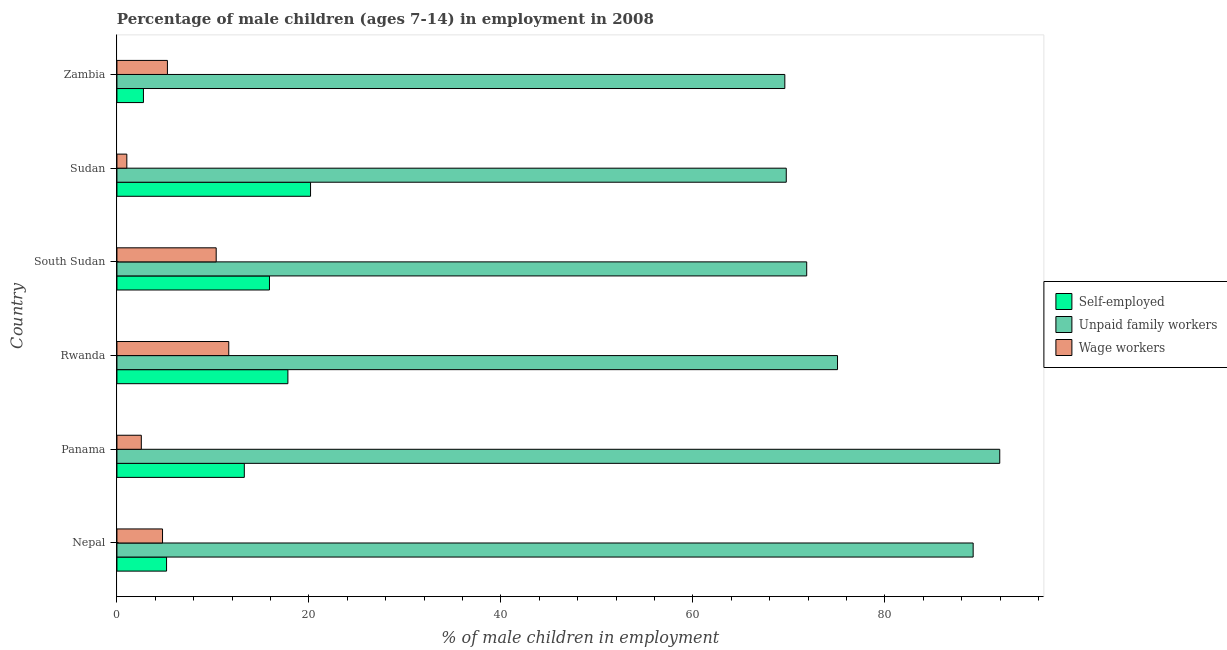How many bars are there on the 2nd tick from the bottom?
Provide a succinct answer. 3. What is the label of the 1st group of bars from the top?
Ensure brevity in your answer.  Zambia. In how many cases, is the number of bars for a given country not equal to the number of legend labels?
Ensure brevity in your answer.  0. What is the percentage of children employed as unpaid family workers in Sudan?
Your response must be concise. 69.73. Across all countries, what is the maximum percentage of children employed as wage workers?
Your response must be concise. 11.65. Across all countries, what is the minimum percentage of self employed children?
Ensure brevity in your answer.  2.76. In which country was the percentage of children employed as unpaid family workers maximum?
Ensure brevity in your answer.  Panama. In which country was the percentage of children employed as wage workers minimum?
Provide a short and direct response. Sudan. What is the total percentage of children employed as unpaid family workers in the graph?
Your answer should be very brief. 467.41. What is the difference between the percentage of children employed as wage workers in Rwanda and that in Zambia?
Provide a short and direct response. 6.39. What is the difference between the percentage of self employed children in Zambia and the percentage of children employed as wage workers in Sudan?
Provide a short and direct response. 1.73. What is the average percentage of children employed as wage workers per country?
Keep it short and to the point. 5.93. What is the difference between the percentage of children employed as unpaid family workers and percentage of self employed children in Rwanda?
Provide a short and direct response. 57.26. What is the ratio of the percentage of children employed as wage workers in Rwanda to that in South Sudan?
Make the answer very short. 1.13. Is the percentage of children employed as unpaid family workers in Panama less than that in Rwanda?
Keep it short and to the point. No. What is the difference between the highest and the second highest percentage of self employed children?
Offer a terse response. 2.36. What is the difference between the highest and the lowest percentage of children employed as wage workers?
Provide a short and direct response. 10.62. In how many countries, is the percentage of children employed as unpaid family workers greater than the average percentage of children employed as unpaid family workers taken over all countries?
Your answer should be compact. 2. Is the sum of the percentage of children employed as wage workers in South Sudan and Sudan greater than the maximum percentage of children employed as unpaid family workers across all countries?
Offer a very short reply. No. What does the 2nd bar from the top in Rwanda represents?
Offer a terse response. Unpaid family workers. What does the 3rd bar from the bottom in South Sudan represents?
Offer a very short reply. Wage workers. How many countries are there in the graph?
Your answer should be compact. 6. Are the values on the major ticks of X-axis written in scientific E-notation?
Offer a terse response. No. Does the graph contain any zero values?
Your response must be concise. No. How are the legend labels stacked?
Provide a succinct answer. Vertical. What is the title of the graph?
Keep it short and to the point. Percentage of male children (ages 7-14) in employment in 2008. Does "Communicable diseases" appear as one of the legend labels in the graph?
Your answer should be compact. No. What is the label or title of the X-axis?
Your answer should be very brief. % of male children in employment. What is the label or title of the Y-axis?
Your answer should be compact. Country. What is the % of male children in employment in Self-employed in Nepal?
Provide a short and direct response. 5.17. What is the % of male children in employment in Unpaid family workers in Nepal?
Keep it short and to the point. 89.2. What is the % of male children in employment of Wage workers in Nepal?
Your response must be concise. 4.75. What is the % of male children in employment in Self-employed in Panama?
Make the answer very short. 13.27. What is the % of male children in employment of Unpaid family workers in Panama?
Your answer should be compact. 91.97. What is the % of male children in employment of Wage workers in Panama?
Ensure brevity in your answer.  2.54. What is the % of male children in employment of Self-employed in Rwanda?
Provide a short and direct response. 17.81. What is the % of male children in employment in Unpaid family workers in Rwanda?
Offer a very short reply. 75.07. What is the % of male children in employment of Wage workers in Rwanda?
Provide a succinct answer. 11.65. What is the % of male children in employment in Self-employed in South Sudan?
Provide a succinct answer. 15.89. What is the % of male children in employment of Unpaid family workers in South Sudan?
Give a very brief answer. 71.86. What is the % of male children in employment of Wage workers in South Sudan?
Offer a terse response. 10.34. What is the % of male children in employment in Self-employed in Sudan?
Give a very brief answer. 20.17. What is the % of male children in employment in Unpaid family workers in Sudan?
Your response must be concise. 69.73. What is the % of male children in employment in Self-employed in Zambia?
Ensure brevity in your answer.  2.76. What is the % of male children in employment in Unpaid family workers in Zambia?
Your answer should be compact. 69.58. What is the % of male children in employment of Wage workers in Zambia?
Provide a short and direct response. 5.26. Across all countries, what is the maximum % of male children in employment in Self-employed?
Ensure brevity in your answer.  20.17. Across all countries, what is the maximum % of male children in employment of Unpaid family workers?
Offer a terse response. 91.97. Across all countries, what is the maximum % of male children in employment in Wage workers?
Offer a very short reply. 11.65. Across all countries, what is the minimum % of male children in employment of Self-employed?
Ensure brevity in your answer.  2.76. Across all countries, what is the minimum % of male children in employment of Unpaid family workers?
Keep it short and to the point. 69.58. What is the total % of male children in employment in Self-employed in the graph?
Make the answer very short. 75.07. What is the total % of male children in employment in Unpaid family workers in the graph?
Ensure brevity in your answer.  467.41. What is the total % of male children in employment of Wage workers in the graph?
Give a very brief answer. 35.57. What is the difference between the % of male children in employment in Unpaid family workers in Nepal and that in Panama?
Your answer should be compact. -2.77. What is the difference between the % of male children in employment in Wage workers in Nepal and that in Panama?
Give a very brief answer. 2.21. What is the difference between the % of male children in employment in Self-employed in Nepal and that in Rwanda?
Offer a very short reply. -12.64. What is the difference between the % of male children in employment of Unpaid family workers in Nepal and that in Rwanda?
Make the answer very short. 14.13. What is the difference between the % of male children in employment of Wage workers in Nepal and that in Rwanda?
Make the answer very short. -6.9. What is the difference between the % of male children in employment of Self-employed in Nepal and that in South Sudan?
Make the answer very short. -10.72. What is the difference between the % of male children in employment in Unpaid family workers in Nepal and that in South Sudan?
Your answer should be compact. 17.34. What is the difference between the % of male children in employment in Wage workers in Nepal and that in South Sudan?
Make the answer very short. -5.59. What is the difference between the % of male children in employment in Self-employed in Nepal and that in Sudan?
Offer a terse response. -15. What is the difference between the % of male children in employment in Unpaid family workers in Nepal and that in Sudan?
Keep it short and to the point. 19.47. What is the difference between the % of male children in employment in Wage workers in Nepal and that in Sudan?
Your answer should be compact. 3.72. What is the difference between the % of male children in employment of Self-employed in Nepal and that in Zambia?
Give a very brief answer. 2.41. What is the difference between the % of male children in employment of Unpaid family workers in Nepal and that in Zambia?
Give a very brief answer. 19.62. What is the difference between the % of male children in employment in Wage workers in Nepal and that in Zambia?
Offer a very short reply. -0.51. What is the difference between the % of male children in employment in Self-employed in Panama and that in Rwanda?
Your response must be concise. -4.54. What is the difference between the % of male children in employment of Wage workers in Panama and that in Rwanda?
Offer a very short reply. -9.11. What is the difference between the % of male children in employment of Self-employed in Panama and that in South Sudan?
Your answer should be very brief. -2.62. What is the difference between the % of male children in employment in Unpaid family workers in Panama and that in South Sudan?
Ensure brevity in your answer.  20.11. What is the difference between the % of male children in employment of Wage workers in Panama and that in South Sudan?
Make the answer very short. -7.8. What is the difference between the % of male children in employment in Self-employed in Panama and that in Sudan?
Ensure brevity in your answer.  -6.9. What is the difference between the % of male children in employment of Unpaid family workers in Panama and that in Sudan?
Offer a very short reply. 22.24. What is the difference between the % of male children in employment of Wage workers in Panama and that in Sudan?
Your response must be concise. 1.51. What is the difference between the % of male children in employment of Self-employed in Panama and that in Zambia?
Ensure brevity in your answer.  10.51. What is the difference between the % of male children in employment of Unpaid family workers in Panama and that in Zambia?
Keep it short and to the point. 22.39. What is the difference between the % of male children in employment in Wage workers in Panama and that in Zambia?
Give a very brief answer. -2.72. What is the difference between the % of male children in employment in Self-employed in Rwanda and that in South Sudan?
Give a very brief answer. 1.92. What is the difference between the % of male children in employment in Unpaid family workers in Rwanda and that in South Sudan?
Provide a succinct answer. 3.21. What is the difference between the % of male children in employment in Wage workers in Rwanda and that in South Sudan?
Ensure brevity in your answer.  1.31. What is the difference between the % of male children in employment in Self-employed in Rwanda and that in Sudan?
Give a very brief answer. -2.36. What is the difference between the % of male children in employment of Unpaid family workers in Rwanda and that in Sudan?
Ensure brevity in your answer.  5.34. What is the difference between the % of male children in employment of Wage workers in Rwanda and that in Sudan?
Provide a short and direct response. 10.62. What is the difference between the % of male children in employment in Self-employed in Rwanda and that in Zambia?
Provide a short and direct response. 15.05. What is the difference between the % of male children in employment of Unpaid family workers in Rwanda and that in Zambia?
Ensure brevity in your answer.  5.49. What is the difference between the % of male children in employment in Wage workers in Rwanda and that in Zambia?
Your answer should be very brief. 6.39. What is the difference between the % of male children in employment in Self-employed in South Sudan and that in Sudan?
Your answer should be compact. -4.28. What is the difference between the % of male children in employment in Unpaid family workers in South Sudan and that in Sudan?
Your response must be concise. 2.13. What is the difference between the % of male children in employment in Wage workers in South Sudan and that in Sudan?
Ensure brevity in your answer.  9.31. What is the difference between the % of male children in employment in Self-employed in South Sudan and that in Zambia?
Your response must be concise. 13.13. What is the difference between the % of male children in employment in Unpaid family workers in South Sudan and that in Zambia?
Your answer should be very brief. 2.28. What is the difference between the % of male children in employment in Wage workers in South Sudan and that in Zambia?
Give a very brief answer. 5.08. What is the difference between the % of male children in employment in Self-employed in Sudan and that in Zambia?
Make the answer very short. 17.41. What is the difference between the % of male children in employment in Unpaid family workers in Sudan and that in Zambia?
Give a very brief answer. 0.15. What is the difference between the % of male children in employment in Wage workers in Sudan and that in Zambia?
Your answer should be compact. -4.23. What is the difference between the % of male children in employment in Self-employed in Nepal and the % of male children in employment in Unpaid family workers in Panama?
Provide a succinct answer. -86.8. What is the difference between the % of male children in employment of Self-employed in Nepal and the % of male children in employment of Wage workers in Panama?
Your response must be concise. 2.63. What is the difference between the % of male children in employment in Unpaid family workers in Nepal and the % of male children in employment in Wage workers in Panama?
Give a very brief answer. 86.66. What is the difference between the % of male children in employment of Self-employed in Nepal and the % of male children in employment of Unpaid family workers in Rwanda?
Your answer should be compact. -69.9. What is the difference between the % of male children in employment in Self-employed in Nepal and the % of male children in employment in Wage workers in Rwanda?
Your answer should be compact. -6.48. What is the difference between the % of male children in employment of Unpaid family workers in Nepal and the % of male children in employment of Wage workers in Rwanda?
Give a very brief answer. 77.55. What is the difference between the % of male children in employment of Self-employed in Nepal and the % of male children in employment of Unpaid family workers in South Sudan?
Your answer should be very brief. -66.69. What is the difference between the % of male children in employment in Self-employed in Nepal and the % of male children in employment in Wage workers in South Sudan?
Your answer should be compact. -5.17. What is the difference between the % of male children in employment in Unpaid family workers in Nepal and the % of male children in employment in Wage workers in South Sudan?
Give a very brief answer. 78.86. What is the difference between the % of male children in employment in Self-employed in Nepal and the % of male children in employment in Unpaid family workers in Sudan?
Provide a succinct answer. -64.56. What is the difference between the % of male children in employment in Self-employed in Nepal and the % of male children in employment in Wage workers in Sudan?
Keep it short and to the point. 4.14. What is the difference between the % of male children in employment in Unpaid family workers in Nepal and the % of male children in employment in Wage workers in Sudan?
Your answer should be very brief. 88.17. What is the difference between the % of male children in employment of Self-employed in Nepal and the % of male children in employment of Unpaid family workers in Zambia?
Make the answer very short. -64.41. What is the difference between the % of male children in employment of Self-employed in Nepal and the % of male children in employment of Wage workers in Zambia?
Give a very brief answer. -0.09. What is the difference between the % of male children in employment of Unpaid family workers in Nepal and the % of male children in employment of Wage workers in Zambia?
Ensure brevity in your answer.  83.94. What is the difference between the % of male children in employment of Self-employed in Panama and the % of male children in employment of Unpaid family workers in Rwanda?
Your answer should be very brief. -61.8. What is the difference between the % of male children in employment in Self-employed in Panama and the % of male children in employment in Wage workers in Rwanda?
Your answer should be very brief. 1.62. What is the difference between the % of male children in employment of Unpaid family workers in Panama and the % of male children in employment of Wage workers in Rwanda?
Offer a terse response. 80.32. What is the difference between the % of male children in employment of Self-employed in Panama and the % of male children in employment of Unpaid family workers in South Sudan?
Offer a very short reply. -58.59. What is the difference between the % of male children in employment of Self-employed in Panama and the % of male children in employment of Wage workers in South Sudan?
Your answer should be very brief. 2.93. What is the difference between the % of male children in employment of Unpaid family workers in Panama and the % of male children in employment of Wage workers in South Sudan?
Your answer should be very brief. 81.63. What is the difference between the % of male children in employment in Self-employed in Panama and the % of male children in employment in Unpaid family workers in Sudan?
Offer a very short reply. -56.46. What is the difference between the % of male children in employment of Self-employed in Panama and the % of male children in employment of Wage workers in Sudan?
Make the answer very short. 12.24. What is the difference between the % of male children in employment in Unpaid family workers in Panama and the % of male children in employment in Wage workers in Sudan?
Make the answer very short. 90.94. What is the difference between the % of male children in employment of Self-employed in Panama and the % of male children in employment of Unpaid family workers in Zambia?
Keep it short and to the point. -56.31. What is the difference between the % of male children in employment of Self-employed in Panama and the % of male children in employment of Wage workers in Zambia?
Offer a terse response. 8.01. What is the difference between the % of male children in employment in Unpaid family workers in Panama and the % of male children in employment in Wage workers in Zambia?
Offer a terse response. 86.71. What is the difference between the % of male children in employment in Self-employed in Rwanda and the % of male children in employment in Unpaid family workers in South Sudan?
Your answer should be very brief. -54.05. What is the difference between the % of male children in employment of Self-employed in Rwanda and the % of male children in employment of Wage workers in South Sudan?
Ensure brevity in your answer.  7.47. What is the difference between the % of male children in employment of Unpaid family workers in Rwanda and the % of male children in employment of Wage workers in South Sudan?
Keep it short and to the point. 64.73. What is the difference between the % of male children in employment in Self-employed in Rwanda and the % of male children in employment in Unpaid family workers in Sudan?
Offer a very short reply. -51.92. What is the difference between the % of male children in employment in Self-employed in Rwanda and the % of male children in employment in Wage workers in Sudan?
Ensure brevity in your answer.  16.78. What is the difference between the % of male children in employment in Unpaid family workers in Rwanda and the % of male children in employment in Wage workers in Sudan?
Offer a very short reply. 74.04. What is the difference between the % of male children in employment in Self-employed in Rwanda and the % of male children in employment in Unpaid family workers in Zambia?
Offer a very short reply. -51.77. What is the difference between the % of male children in employment of Self-employed in Rwanda and the % of male children in employment of Wage workers in Zambia?
Your response must be concise. 12.55. What is the difference between the % of male children in employment of Unpaid family workers in Rwanda and the % of male children in employment of Wage workers in Zambia?
Provide a succinct answer. 69.81. What is the difference between the % of male children in employment in Self-employed in South Sudan and the % of male children in employment in Unpaid family workers in Sudan?
Your response must be concise. -53.84. What is the difference between the % of male children in employment of Self-employed in South Sudan and the % of male children in employment of Wage workers in Sudan?
Your answer should be very brief. 14.86. What is the difference between the % of male children in employment in Unpaid family workers in South Sudan and the % of male children in employment in Wage workers in Sudan?
Offer a terse response. 70.83. What is the difference between the % of male children in employment of Self-employed in South Sudan and the % of male children in employment of Unpaid family workers in Zambia?
Provide a short and direct response. -53.69. What is the difference between the % of male children in employment of Self-employed in South Sudan and the % of male children in employment of Wage workers in Zambia?
Your answer should be compact. 10.63. What is the difference between the % of male children in employment in Unpaid family workers in South Sudan and the % of male children in employment in Wage workers in Zambia?
Your answer should be compact. 66.6. What is the difference between the % of male children in employment of Self-employed in Sudan and the % of male children in employment of Unpaid family workers in Zambia?
Provide a succinct answer. -49.41. What is the difference between the % of male children in employment in Self-employed in Sudan and the % of male children in employment in Wage workers in Zambia?
Your answer should be compact. 14.91. What is the difference between the % of male children in employment in Unpaid family workers in Sudan and the % of male children in employment in Wage workers in Zambia?
Provide a short and direct response. 64.47. What is the average % of male children in employment of Self-employed per country?
Your response must be concise. 12.51. What is the average % of male children in employment in Unpaid family workers per country?
Offer a terse response. 77.9. What is the average % of male children in employment of Wage workers per country?
Your answer should be very brief. 5.93. What is the difference between the % of male children in employment in Self-employed and % of male children in employment in Unpaid family workers in Nepal?
Your answer should be compact. -84.03. What is the difference between the % of male children in employment of Self-employed and % of male children in employment of Wage workers in Nepal?
Your answer should be very brief. 0.42. What is the difference between the % of male children in employment of Unpaid family workers and % of male children in employment of Wage workers in Nepal?
Keep it short and to the point. 84.45. What is the difference between the % of male children in employment of Self-employed and % of male children in employment of Unpaid family workers in Panama?
Offer a terse response. -78.7. What is the difference between the % of male children in employment in Self-employed and % of male children in employment in Wage workers in Panama?
Ensure brevity in your answer.  10.73. What is the difference between the % of male children in employment in Unpaid family workers and % of male children in employment in Wage workers in Panama?
Your response must be concise. 89.43. What is the difference between the % of male children in employment of Self-employed and % of male children in employment of Unpaid family workers in Rwanda?
Provide a short and direct response. -57.26. What is the difference between the % of male children in employment of Self-employed and % of male children in employment of Wage workers in Rwanda?
Your response must be concise. 6.16. What is the difference between the % of male children in employment of Unpaid family workers and % of male children in employment of Wage workers in Rwanda?
Offer a very short reply. 63.42. What is the difference between the % of male children in employment in Self-employed and % of male children in employment in Unpaid family workers in South Sudan?
Provide a succinct answer. -55.97. What is the difference between the % of male children in employment in Self-employed and % of male children in employment in Wage workers in South Sudan?
Keep it short and to the point. 5.55. What is the difference between the % of male children in employment in Unpaid family workers and % of male children in employment in Wage workers in South Sudan?
Give a very brief answer. 61.52. What is the difference between the % of male children in employment in Self-employed and % of male children in employment in Unpaid family workers in Sudan?
Offer a very short reply. -49.56. What is the difference between the % of male children in employment of Self-employed and % of male children in employment of Wage workers in Sudan?
Offer a terse response. 19.14. What is the difference between the % of male children in employment in Unpaid family workers and % of male children in employment in Wage workers in Sudan?
Give a very brief answer. 68.7. What is the difference between the % of male children in employment in Self-employed and % of male children in employment in Unpaid family workers in Zambia?
Ensure brevity in your answer.  -66.82. What is the difference between the % of male children in employment of Self-employed and % of male children in employment of Wage workers in Zambia?
Offer a terse response. -2.5. What is the difference between the % of male children in employment of Unpaid family workers and % of male children in employment of Wage workers in Zambia?
Offer a very short reply. 64.32. What is the ratio of the % of male children in employment in Self-employed in Nepal to that in Panama?
Your response must be concise. 0.39. What is the ratio of the % of male children in employment of Unpaid family workers in Nepal to that in Panama?
Make the answer very short. 0.97. What is the ratio of the % of male children in employment of Wage workers in Nepal to that in Panama?
Give a very brief answer. 1.87. What is the ratio of the % of male children in employment of Self-employed in Nepal to that in Rwanda?
Your answer should be compact. 0.29. What is the ratio of the % of male children in employment in Unpaid family workers in Nepal to that in Rwanda?
Your answer should be very brief. 1.19. What is the ratio of the % of male children in employment in Wage workers in Nepal to that in Rwanda?
Your response must be concise. 0.41. What is the ratio of the % of male children in employment of Self-employed in Nepal to that in South Sudan?
Your response must be concise. 0.33. What is the ratio of the % of male children in employment in Unpaid family workers in Nepal to that in South Sudan?
Make the answer very short. 1.24. What is the ratio of the % of male children in employment of Wage workers in Nepal to that in South Sudan?
Provide a succinct answer. 0.46. What is the ratio of the % of male children in employment in Self-employed in Nepal to that in Sudan?
Offer a very short reply. 0.26. What is the ratio of the % of male children in employment in Unpaid family workers in Nepal to that in Sudan?
Make the answer very short. 1.28. What is the ratio of the % of male children in employment in Wage workers in Nepal to that in Sudan?
Provide a short and direct response. 4.61. What is the ratio of the % of male children in employment of Self-employed in Nepal to that in Zambia?
Your answer should be very brief. 1.87. What is the ratio of the % of male children in employment of Unpaid family workers in Nepal to that in Zambia?
Your answer should be compact. 1.28. What is the ratio of the % of male children in employment in Wage workers in Nepal to that in Zambia?
Provide a short and direct response. 0.9. What is the ratio of the % of male children in employment of Self-employed in Panama to that in Rwanda?
Keep it short and to the point. 0.75. What is the ratio of the % of male children in employment in Unpaid family workers in Panama to that in Rwanda?
Offer a terse response. 1.23. What is the ratio of the % of male children in employment in Wage workers in Panama to that in Rwanda?
Your response must be concise. 0.22. What is the ratio of the % of male children in employment of Self-employed in Panama to that in South Sudan?
Give a very brief answer. 0.84. What is the ratio of the % of male children in employment in Unpaid family workers in Panama to that in South Sudan?
Offer a very short reply. 1.28. What is the ratio of the % of male children in employment of Wage workers in Panama to that in South Sudan?
Your answer should be very brief. 0.25. What is the ratio of the % of male children in employment of Self-employed in Panama to that in Sudan?
Your response must be concise. 0.66. What is the ratio of the % of male children in employment in Unpaid family workers in Panama to that in Sudan?
Your answer should be compact. 1.32. What is the ratio of the % of male children in employment of Wage workers in Panama to that in Sudan?
Make the answer very short. 2.47. What is the ratio of the % of male children in employment in Self-employed in Panama to that in Zambia?
Your response must be concise. 4.81. What is the ratio of the % of male children in employment in Unpaid family workers in Panama to that in Zambia?
Ensure brevity in your answer.  1.32. What is the ratio of the % of male children in employment in Wage workers in Panama to that in Zambia?
Offer a very short reply. 0.48. What is the ratio of the % of male children in employment in Self-employed in Rwanda to that in South Sudan?
Keep it short and to the point. 1.12. What is the ratio of the % of male children in employment of Unpaid family workers in Rwanda to that in South Sudan?
Offer a terse response. 1.04. What is the ratio of the % of male children in employment in Wage workers in Rwanda to that in South Sudan?
Provide a succinct answer. 1.13. What is the ratio of the % of male children in employment of Self-employed in Rwanda to that in Sudan?
Provide a short and direct response. 0.88. What is the ratio of the % of male children in employment in Unpaid family workers in Rwanda to that in Sudan?
Ensure brevity in your answer.  1.08. What is the ratio of the % of male children in employment in Wage workers in Rwanda to that in Sudan?
Your response must be concise. 11.31. What is the ratio of the % of male children in employment of Self-employed in Rwanda to that in Zambia?
Provide a succinct answer. 6.45. What is the ratio of the % of male children in employment in Unpaid family workers in Rwanda to that in Zambia?
Give a very brief answer. 1.08. What is the ratio of the % of male children in employment in Wage workers in Rwanda to that in Zambia?
Offer a terse response. 2.21. What is the ratio of the % of male children in employment in Self-employed in South Sudan to that in Sudan?
Offer a very short reply. 0.79. What is the ratio of the % of male children in employment of Unpaid family workers in South Sudan to that in Sudan?
Offer a terse response. 1.03. What is the ratio of the % of male children in employment of Wage workers in South Sudan to that in Sudan?
Your response must be concise. 10.04. What is the ratio of the % of male children in employment in Self-employed in South Sudan to that in Zambia?
Your response must be concise. 5.76. What is the ratio of the % of male children in employment of Unpaid family workers in South Sudan to that in Zambia?
Your answer should be very brief. 1.03. What is the ratio of the % of male children in employment in Wage workers in South Sudan to that in Zambia?
Provide a short and direct response. 1.97. What is the ratio of the % of male children in employment of Self-employed in Sudan to that in Zambia?
Offer a very short reply. 7.31. What is the ratio of the % of male children in employment of Wage workers in Sudan to that in Zambia?
Your response must be concise. 0.2. What is the difference between the highest and the second highest % of male children in employment of Self-employed?
Offer a terse response. 2.36. What is the difference between the highest and the second highest % of male children in employment of Unpaid family workers?
Keep it short and to the point. 2.77. What is the difference between the highest and the second highest % of male children in employment of Wage workers?
Your response must be concise. 1.31. What is the difference between the highest and the lowest % of male children in employment of Self-employed?
Offer a terse response. 17.41. What is the difference between the highest and the lowest % of male children in employment in Unpaid family workers?
Offer a terse response. 22.39. What is the difference between the highest and the lowest % of male children in employment of Wage workers?
Provide a short and direct response. 10.62. 